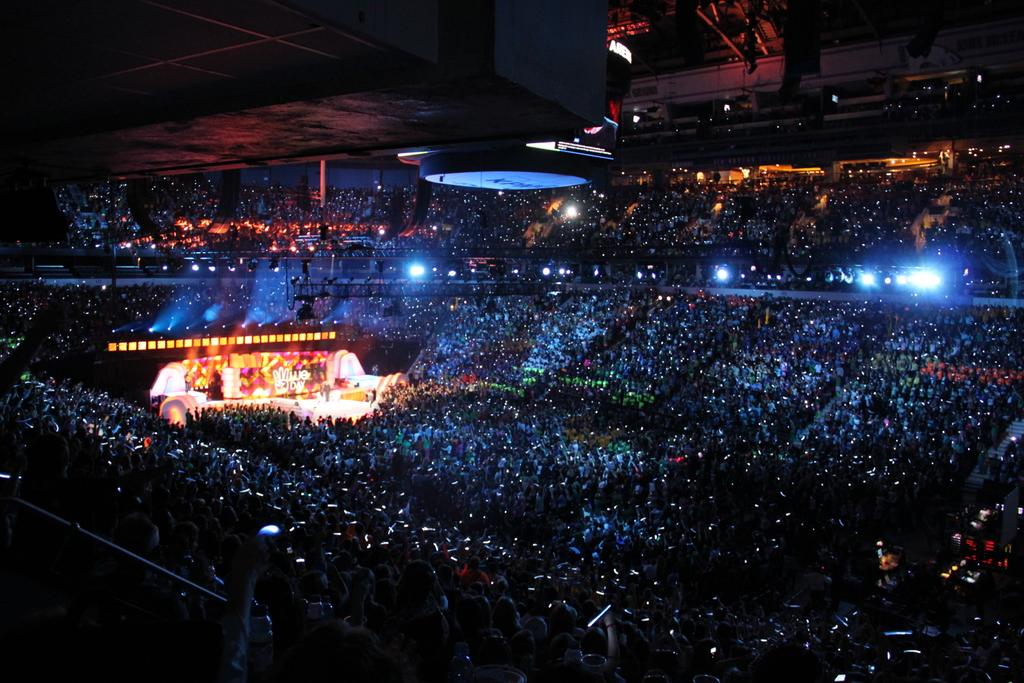What type of event is taking place in the image? The image appears to depict a concert. Where is the main focus of the event located in the image? There is a stage on the left side of the image. How many people are present at the event? A large crowd is present around the stage. What type of cushion is being used by the performer on stage? There is no cushion visible in the image, and the performer's seating arrangement is not mentioned. What religious belief is being practiced by the crowd in the image? There is no indication of any religious beliefs being practiced in the image; it depicts a concert. 